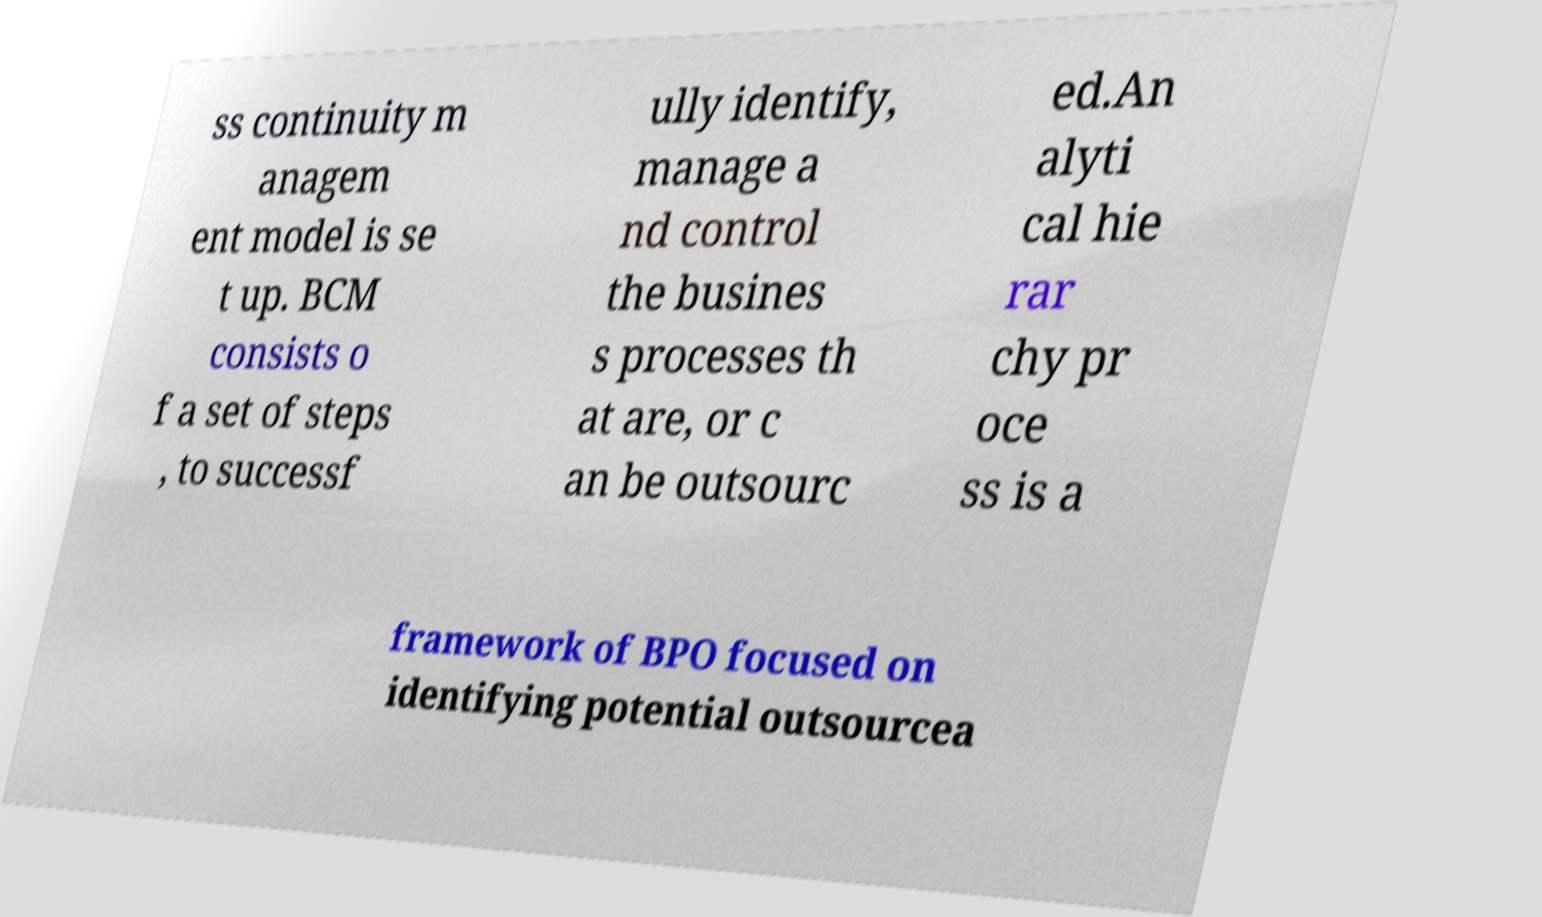I need the written content from this picture converted into text. Can you do that? ss continuity m anagem ent model is se t up. BCM consists o f a set of steps , to successf ully identify, manage a nd control the busines s processes th at are, or c an be outsourc ed.An alyti cal hie rar chy pr oce ss is a framework of BPO focused on identifying potential outsourcea 